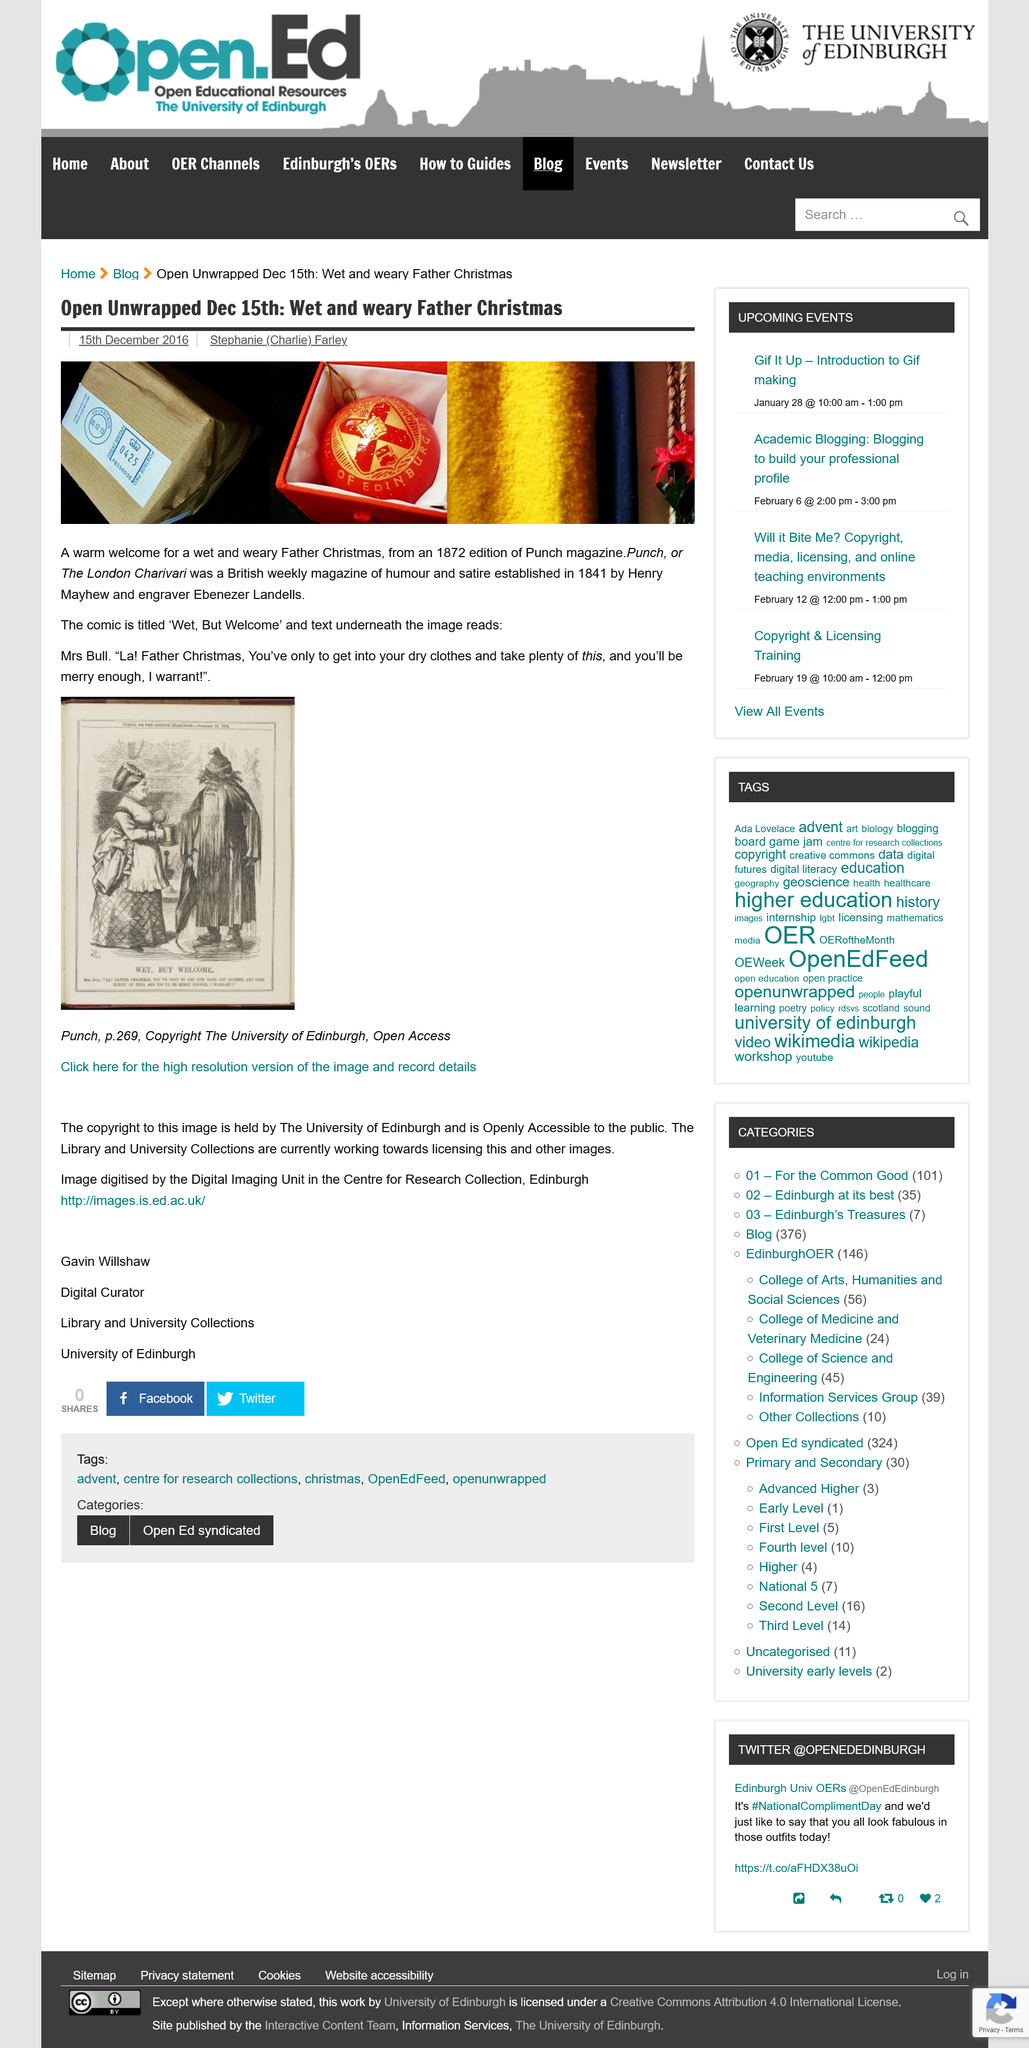Draw attention to some important aspects in this diagram. The illustration on page 264 of the book entitled "Punch" is copyrighted by The University of Edinburgh. The illustration on page 269 of the book "Punch" is openly accessible to the public and can be viewed by anyone. The source of the image is unknown, as it was not explicitly mentioned. However, it is stated that the image is from page 269 of an unknown document or source. The comic from the 1872 edition of Punch magazine is called "Wet, But Welcome. Punch, a magazine, was established by Henry Mayhew and Ebenezer Landells. 